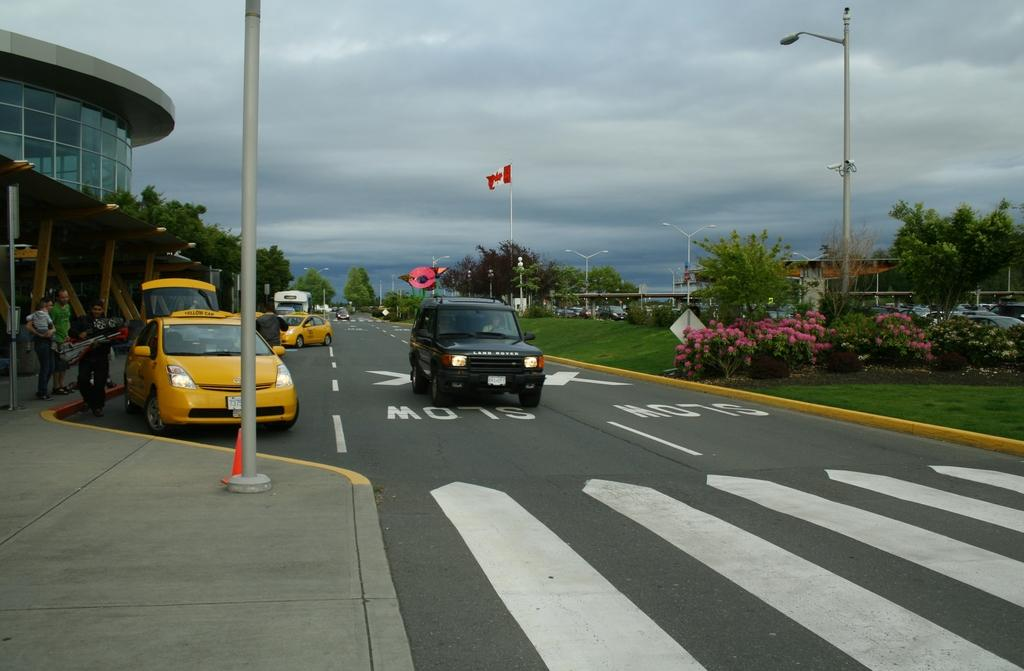<image>
Write a terse but informative summary of the picture. A black Rand Rover drives in the slow area of the road. 